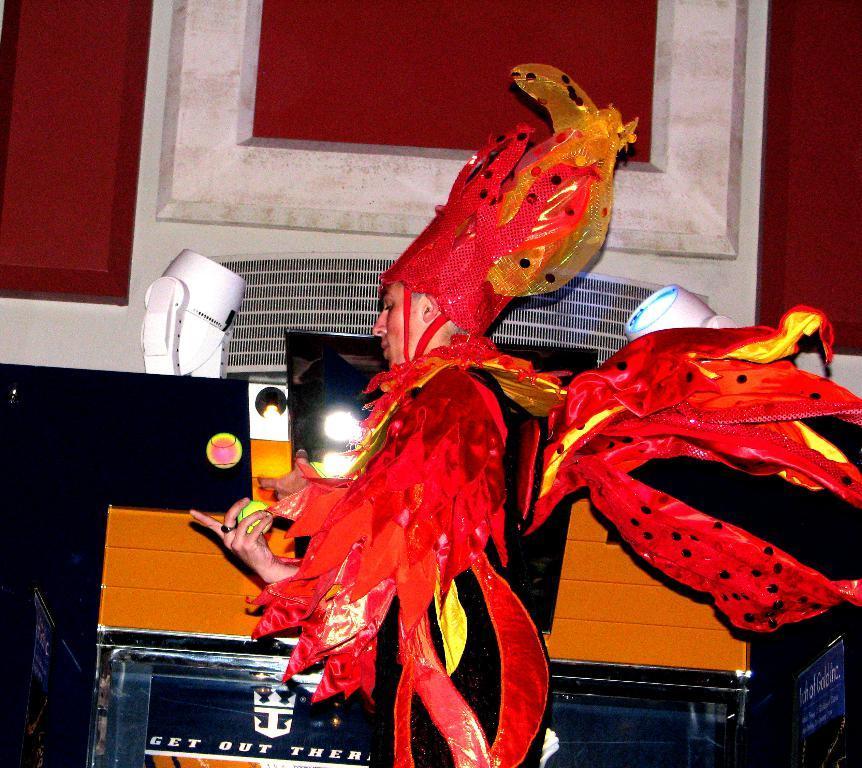Please provide a concise description of this image. In this picture there is a person standing and wore costume and holding a ball and we can see lights, banners and objects. In the background of the image we can see the wall. 